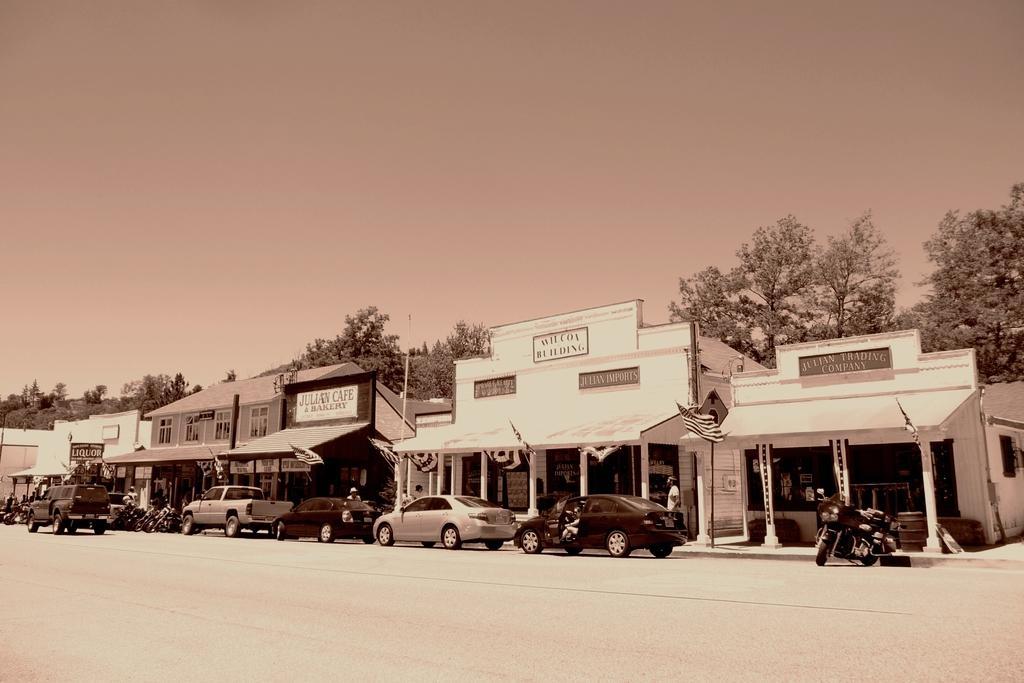How would you summarize this image in a sentence or two? In this image there are vehicles on a road, in the background there are buildings, trees and the sky. 